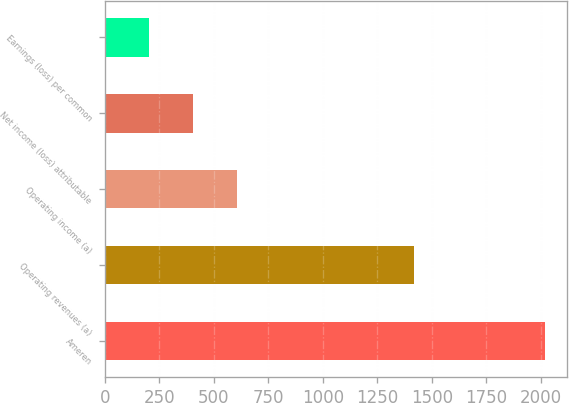Convert chart. <chart><loc_0><loc_0><loc_500><loc_500><bar_chart><fcel>Ameren<fcel>Operating revenues (a)<fcel>Operating income (a)<fcel>Net income (loss) attributable<fcel>Earnings (loss) per common<nl><fcel>2018<fcel>1419<fcel>605.59<fcel>403.82<fcel>202.05<nl></chart> 